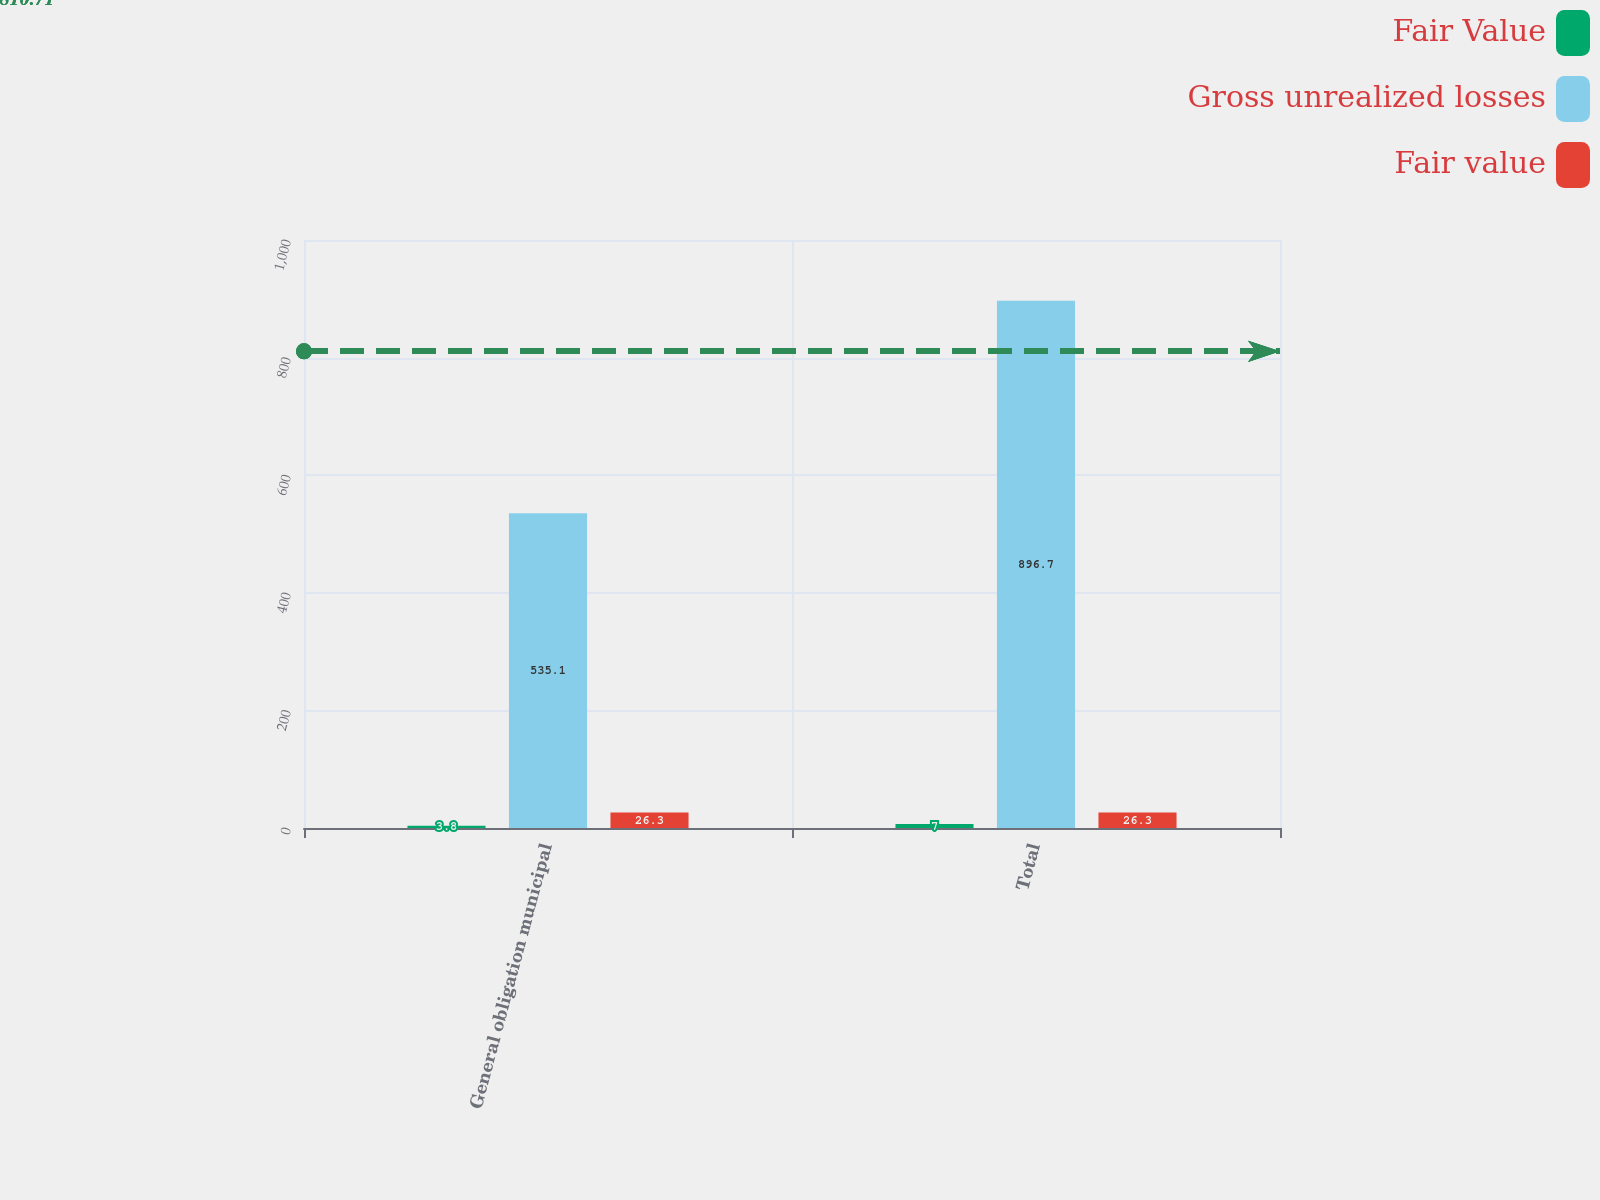<chart> <loc_0><loc_0><loc_500><loc_500><stacked_bar_chart><ecel><fcel>General obligation municipal<fcel>Total<nl><fcel>Fair Value<fcel>3.8<fcel>7<nl><fcel>Gross unrealized losses<fcel>535.1<fcel>896.7<nl><fcel>Fair value<fcel>26.3<fcel>26.3<nl></chart> 